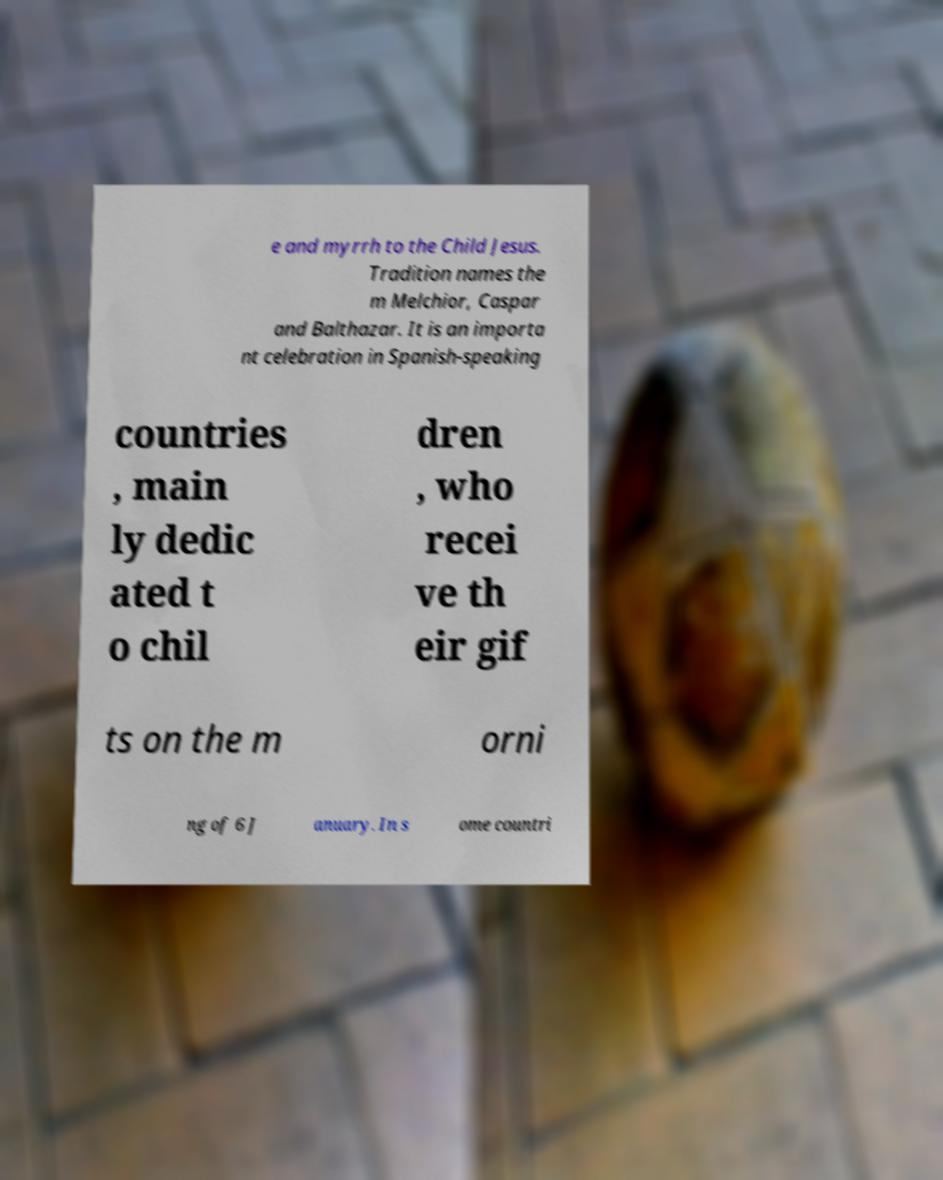For documentation purposes, I need the text within this image transcribed. Could you provide that? e and myrrh to the Child Jesus. Tradition names the m Melchior, Caspar and Balthazar. It is an importa nt celebration in Spanish-speaking countries , main ly dedic ated t o chil dren , who recei ve th eir gif ts on the m orni ng of 6 J anuary. In s ome countri 